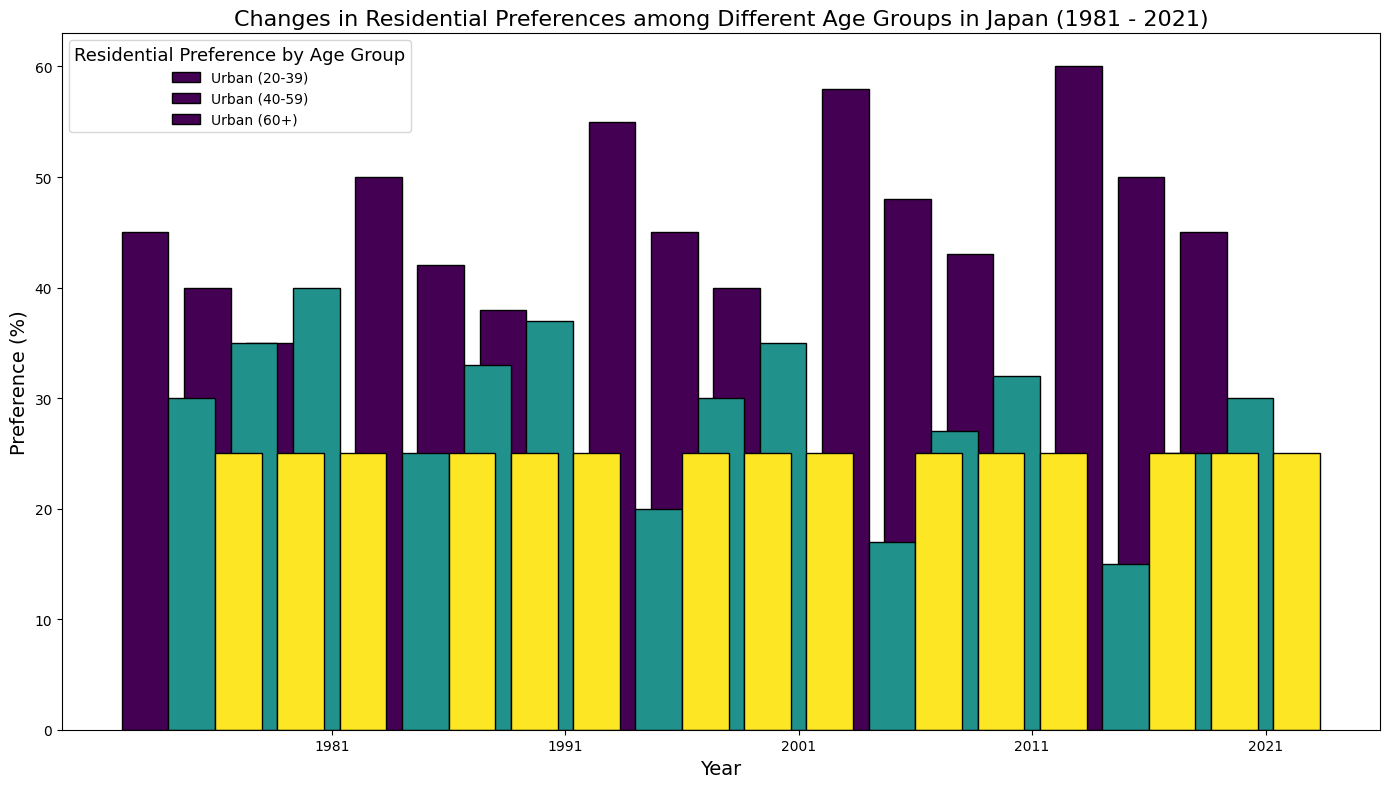What was the percentage of people aged 20-39 living in Urban areas in 1981? To find the percentage of people aged 20-39 living in Urban areas in 1981, we look at the bar corresponding to the 20-39 age group for the year 1981 and check the height associated with Urban areas.
Answer: 45% How did the percentage of people aged 60+ living in Rural areas change from 1981 to 2021? To determine the change, subtract the percentage in 2021 from that in 1981: 40% in 1981 and 30% in 2021. The change is 40% - 30% = 10%.
Answer: Decreased by 10% Which age group showed the largest increase in Urban area preference from 1981 to 2021? Calculate the difference for each age group from 1981 to 2021: 
20-39: 60% - 45% = 15%. 
40-59: 50% - 40% = 10%. 
60+: 45% - 35% = 10%. 
The 20-39 age group has the largest increase.
Answer: 20-39 By how much did the preference for Suburban areas stay constant for all age groups throughout the years? For each year, compare the percentage for Suburban across all age groups:
1981: 25%, 25%, 25%
1991: 25%, 25%, 25%
2001: 25%, 25%, 25%
2011: 25%, 25%, 25%
2021: 25%, 25%, 25%
There is no change, so the preference stayed constant by 0%.
Answer: 0% In 1991, for the age group 40-59, was the preference for Urban areas higher than for Rural areas? Compare the values for Urban and Rural areas: Urban is 42%, Rural is 33%. Urban is higher.
Answer: Yes Which age group had the highest preference for Rural areas in 2001? Compare the values for Rural areas in 2001:
20-39: 20%
40-59: 30%
60+: 35%
The 60+ age group has the highest preference.
Answer: 60+ What is the average preference for Urban areas for all age groups in 2011? Add up the values for Urban areas for all age groups in 2011 and divide by the number of age groups: 
(58% + 48% + 43%) / 3 = 149% / 3 ≈ 49.67%.
Answer: 49.67% What visual difference can you observe between the Urban and Rural preferences for age group 20-39 in 2021? Visually, the bar for Urban is the highest and the bar for Rural is the lowest for this age group in 2021.
Answer: Urban is the highest and Rural is the lowest Between which years did the age group 20-39 see the highest increase in preference for Urban living? Track the increment for Urban living preference for 20-39 across the years:
1981-1991: 50% - 45% = 5%
1991-2001: 55% - 50% = 5%
2001-2011: 58% - 55% = 3%
2011-2021: 60% - 58% = 2%
The highest increase is from 1981 to 1991 and from 1991 to 2001, both 5%.
Answer: 1981-1991 and 1991-2001 